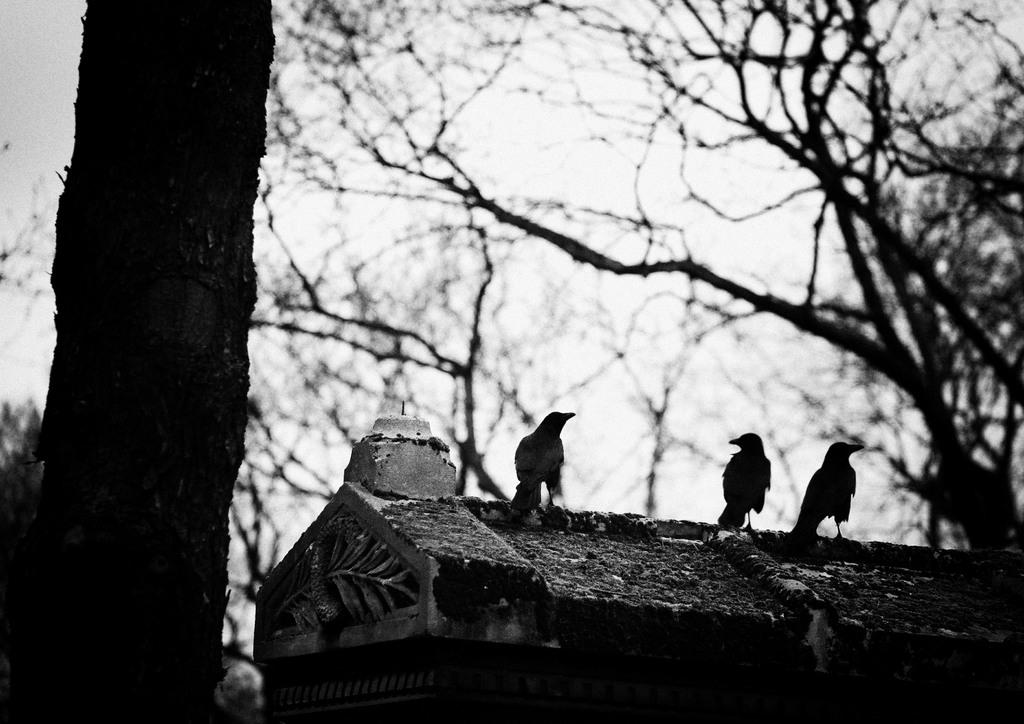What type of vegetation can be seen in the image? There are trees in the image. What animals are present in the image? There are birds in the image. What is the color scheme of the image? The image is black and white in color. How does the friend in the image contribute to the idea of the desire? There is no friend, idea, or desire present in the image; it only features trees and birds in a black and white color scheme. 